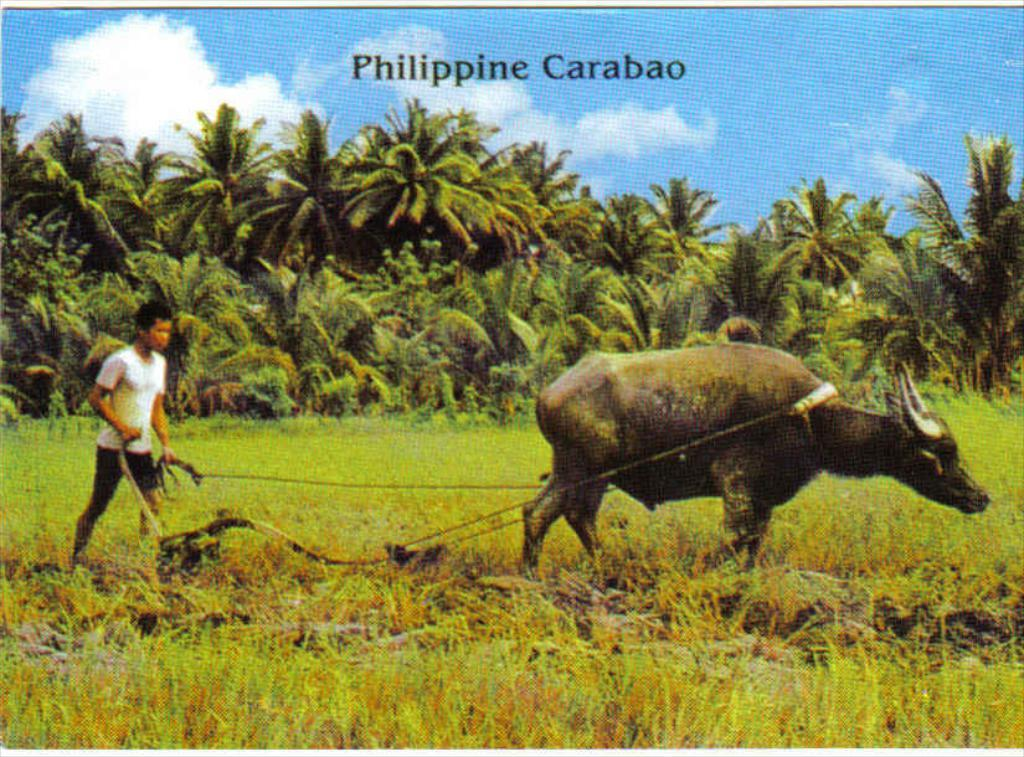What is the man in the image holding? The man is holding a rope and an object. What can be seen in the image besides the man? There is an animal, ropes, a tool, and grass visible in the image. What is the animal in the image? The facts provided do not specify the type of animal in the image. What is the tool used for in the image? The purpose of the tool in the image cannot be determined from the provided facts. What historical event is being commemorated in the image? There is no indication of a historical event being commemorated in the image. 